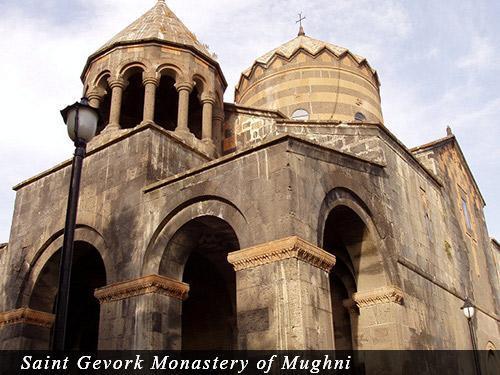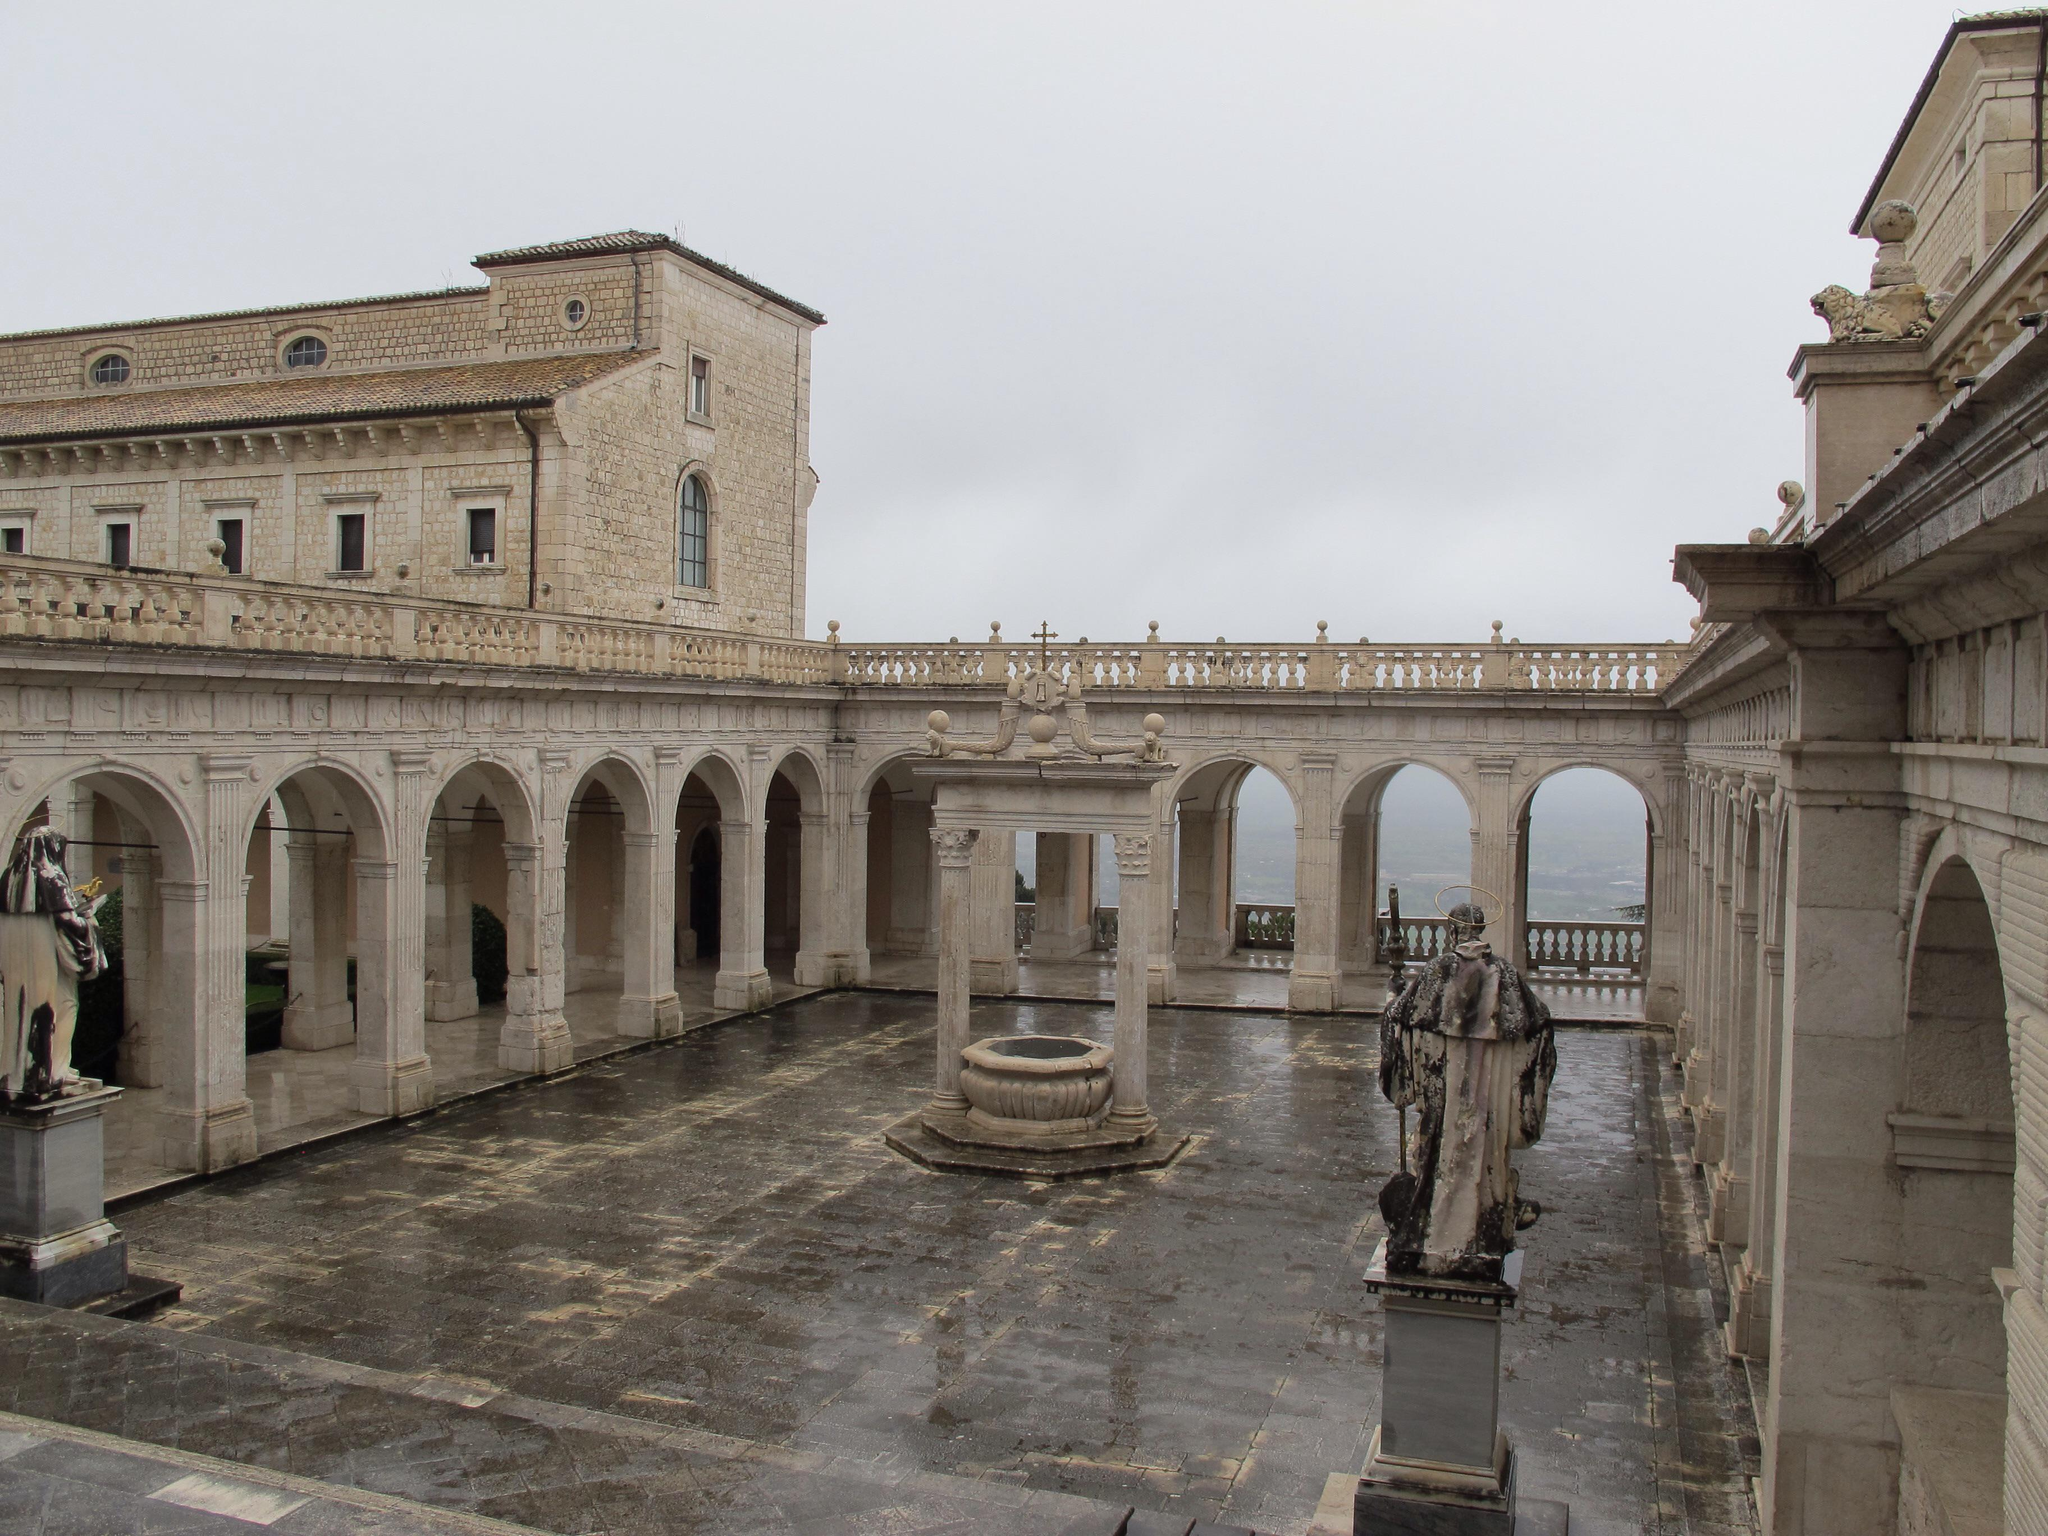The first image is the image on the left, the second image is the image on the right. Considering the images on both sides, is "An image shows a semi-circle of arches, with an opening above them." valid? Answer yes or no. No. The first image is the image on the left, the second image is the image on the right. Considering the images on both sides, is "In one image, a round fountain structure can be seen near long archway passages that run in two directions." valid? Answer yes or no. Yes. 